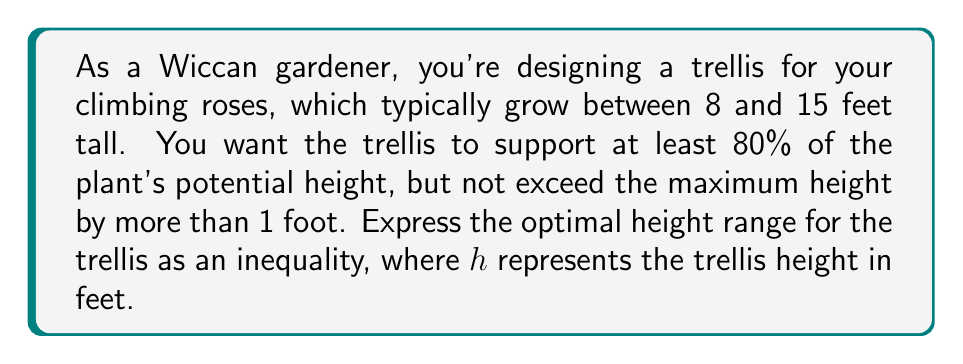Show me your answer to this math problem. To solve this problem, we need to consider both the minimum and maximum constraints for the trellis height:

1. Minimum height constraint:
   The trellis should support at least 80% of the minimum plant height.
   Minimum plant height = 8 feet
   $80\% \text{ of } 8 = 0.8 \times 8 = 6.4$ feet

2. Maximum height constraint:
   The trellis should not exceed the maximum plant height by more than 1 foot.
   Maximum plant height = 15 feet
   Maximum trellis height = $15 + 1 = 16$ feet

Now, we can express these constraints as an inequality:

$$6.4 \leq h \leq 16$$

Where $h$ represents the trellis height in feet.

This inequality ensures that the trellis is tall enough to support at least 80% of the shortest climbing roses (6.4 feet) while not exceeding the height of the tallest roses by more than 1 foot (16 feet).
Answer: $6.4 \leq h \leq 16$, where $h$ is the trellis height in feet. 